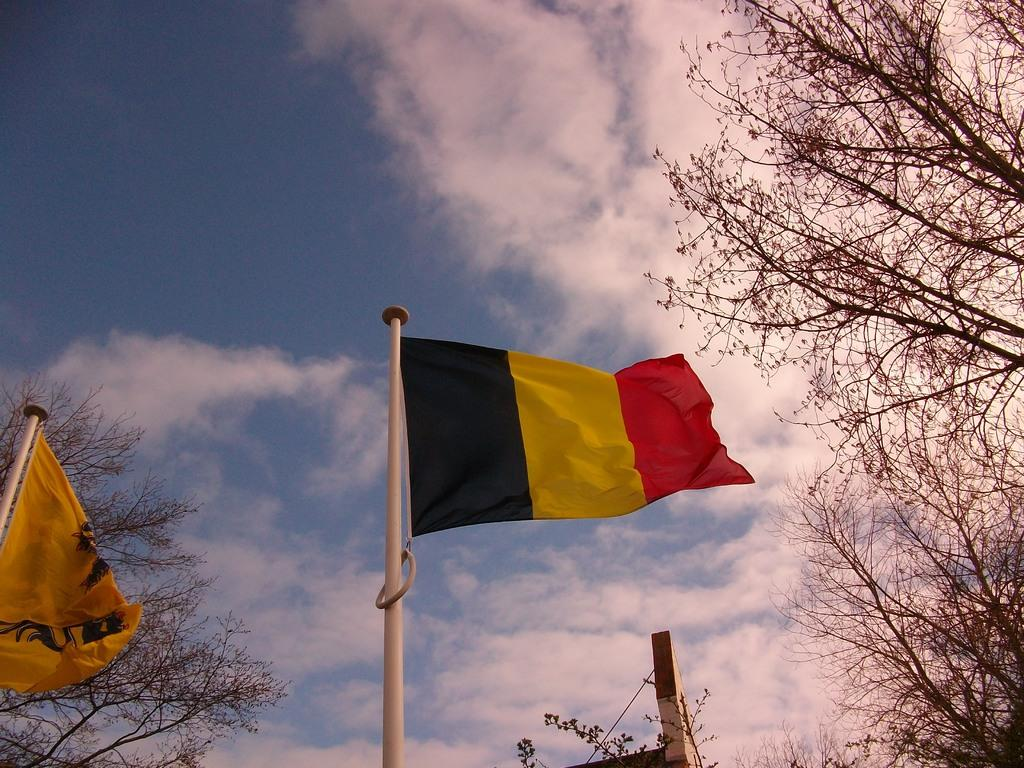How many flags can be seen in the image? There are two flags in the image. What else is present in the image besides the flags? There are trees and an object visible in the image. What is visible in the background of the image? The sky is visible in the background of the image. What can be observed in the sky? Clouds are present in the sky. What type of net is being used to catch the ants in the image? There are no ants or nets present in the image. 